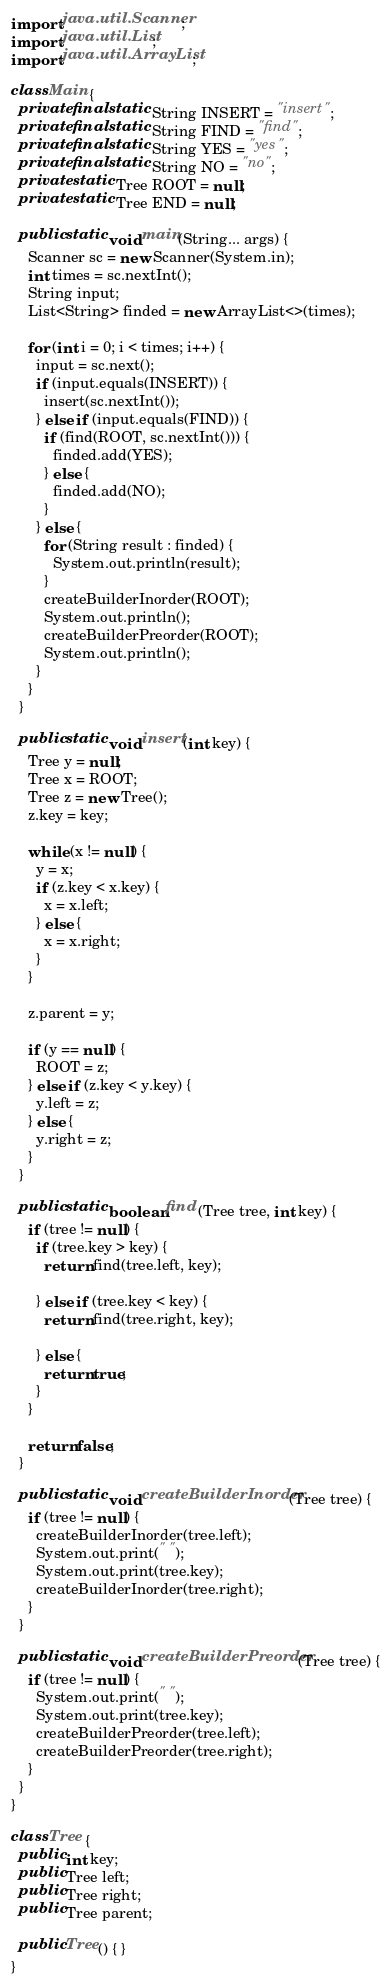<code> <loc_0><loc_0><loc_500><loc_500><_Java_>import java.util.Scanner;
import java.util.List;
import java.util.ArrayList;

class Main {
  private final static String INSERT = "insert";
  private final static String FIND = "find";
  private final static String YES = "yes";
  private final static String NO = "no";
  private static Tree ROOT = null;
  private static Tree END = null;

  public static void main(String... args) {
    Scanner sc = new Scanner(System.in);
    int times = sc.nextInt();
    String input;
    List<String> finded = new ArrayList<>(times);

    for (int i = 0; i < times; i++) {
      input = sc.next();
      if (input.equals(INSERT)) {
        insert(sc.nextInt());
      } else if (input.equals(FIND)) {
        if (find(ROOT, sc.nextInt())) {
          finded.add(YES);
        } else {
          finded.add(NO);
        }
      } else {
        for (String result : finded) {
          System.out.println(result);
        }
        createBuilderInorder(ROOT);
        System.out.println();
        createBuilderPreorder(ROOT);
        System.out.println();
      }
    }
  }

  public static void insert(int key) {
    Tree y = null;
    Tree x = ROOT;
    Tree z = new Tree();
    z.key = key;

    while (x != null) {
      y = x;
      if (z.key < x.key) {
        x = x.left;
      } else {
        x = x.right;
      }
    }

    z.parent = y;

    if (y == null) {
      ROOT = z;
    } else if (z.key < y.key) {
      y.left = z;
    } else {
      y.right = z;
    }
  }

  public static boolean find (Tree tree, int key) {
    if (tree != null) {
      if (tree.key > key) {
        return find(tree.left, key);

      } else if (tree.key < key) {
        return find(tree.right, key);

      } else {
        return true;
      }
    }

    return false;
  }

  public static void createBuilderInorder(Tree tree) {
    if (tree != null) {
      createBuilderInorder(tree.left);
      System.out.print(" ");
      System.out.print(tree.key);
      createBuilderInorder(tree.right);
    }
  }

  public static void createBuilderPreorder(Tree tree) {
    if (tree != null) {
      System.out.print(" ");
      System.out.print(tree.key);
      createBuilderPreorder(tree.left);
      createBuilderPreorder(tree.right);
    }
  }
}

class Tree {
  public int key;
  public Tree left;
  public Tree right;
  public Tree parent;

  public Tree() { }
}

</code> 